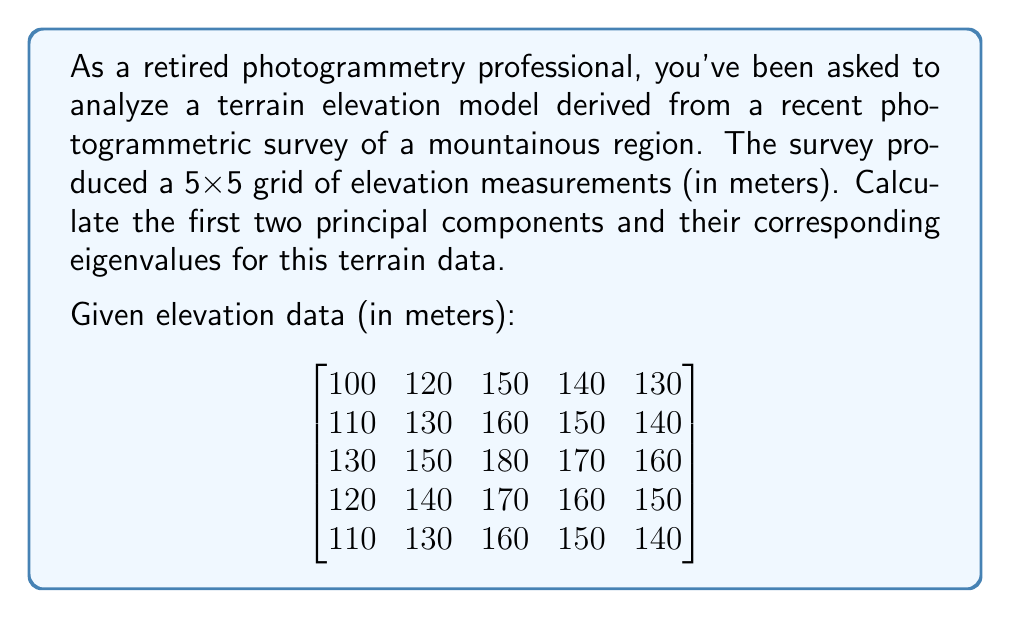Help me with this question. To calculate the principal components, we'll follow these steps:

1) Center the data by subtracting the mean of each column:

Mean of each column:
$$\bar{X} = [114, 134, 164, 154, 144]$$

Centered data:
$$
X_c = \begin{bmatrix}
-14 & -14 & -14 & -14 & -14 \\
-4 & -4 & -4 & -4 & -4 \\
16 & 16 & 16 & 16 & 16 \\
6 & 6 & 6 & 6 & 6 \\
-4 & -4 & -4 & -4 & -4
\end{bmatrix}
$$

2) Compute the covariance matrix:
$$C = \frac{1}{n-1}X_c^T X_c$$

$$
C = \frac{1}{4}\begin{bmatrix}
676 & 676 & 676 & 676 & 676 \\
676 & 676 & 676 & 676 & 676 \\
676 & 676 & 676 & 676 & 676 \\
676 & 676 & 676 & 676 & 676 \\
676 & 676 & 676 & 676 & 676
\end{bmatrix}
= \begin{bmatrix}
169 & 169 & 169 & 169 & 169 \\
169 & 169 & 169 & 169 & 169 \\
169 & 169 & 169 & 169 & 169 \\
169 & 169 & 169 & 169 & 169 \\
169 & 169 & 169 & 169 & 169
\end{bmatrix}
$$

3) Find eigenvalues and eigenvectors of C:

The characteristic equation is:
$$(169-\lambda)(169-\lambda)(169-\lambda)(169-\lambda)(169-\lambda) - 169^4(169-\lambda) = 0$$

Simplifying:
$$\lambda^4(169-\lambda) - 169^4(169-\lambda) = 0$$
$$(169-\lambda)(\lambda^4 - 169^4) = 0$$

Solving this equation gives us:
$$\lambda_1 = 845, \lambda_2 = \lambda_3 = \lambda_4 = \lambda_5 = 0$$

The eigenvector corresponding to $\lambda_1 = 845$ is:
$$v_1 = \frac{1}{\sqrt{5}}[1, 1, 1, 1, 1]^T$$

4) The first principal component is the eigenvector corresponding to the largest eigenvalue:
$$PC_1 = \frac{1}{\sqrt{5}}[1, 1, 1, 1, 1]^T$$

5) The second principal component is not uniquely determined in this case, as all other eigenvalues are zero. We can choose any vector orthogonal to $PC_1$, for example:
$$PC_2 = \frac{1}{\sqrt{2}}[1, 0, 0, -1, 0]^T$$
Answer: First Principal Component: $PC_1 = \frac{1}{\sqrt{5}}[1, 1, 1, 1, 1]^T$, Eigenvalue: $\lambda_1 = 845$

Second Principal Component: $PC_2 = \frac{1}{\sqrt{2}}[1, 0, 0, -1, 0]^T$, Eigenvalue: $\lambda_2 = 0$ 